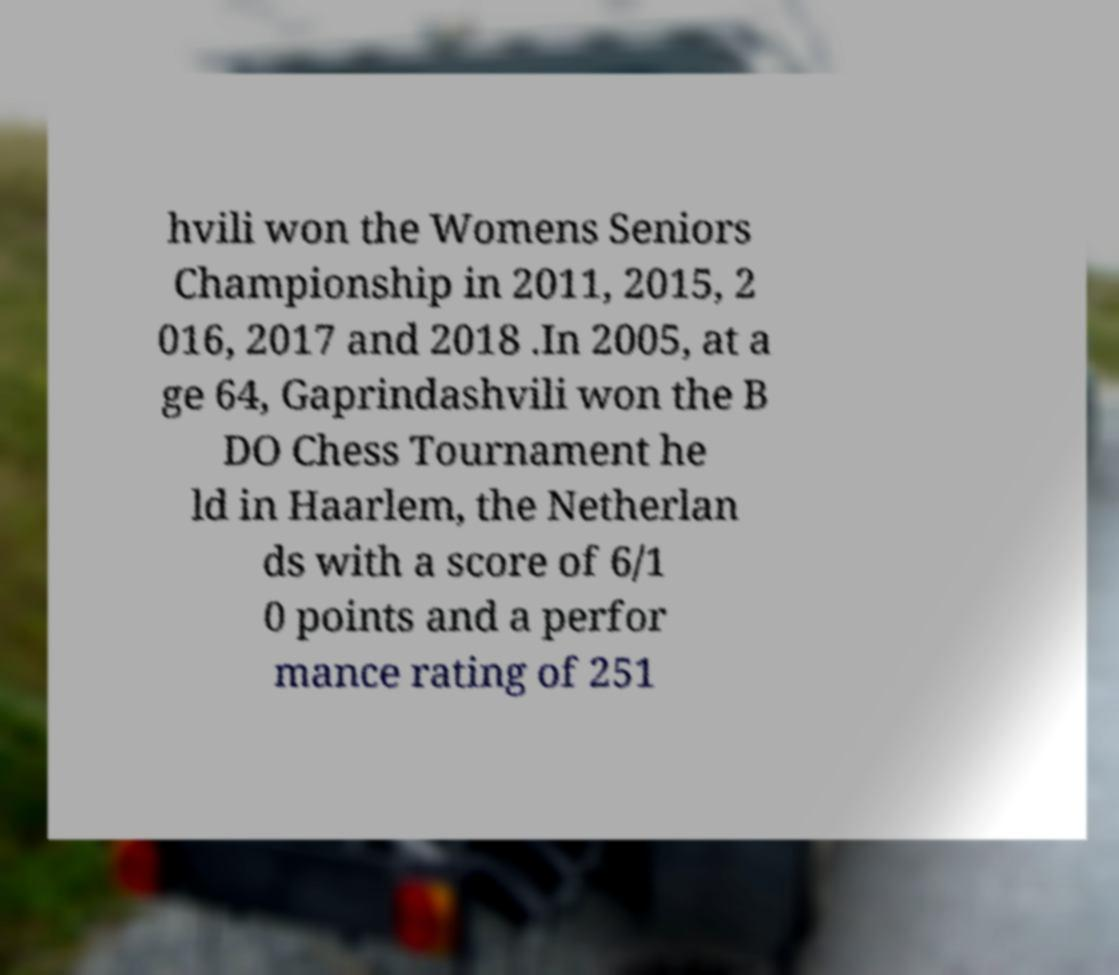For documentation purposes, I need the text within this image transcribed. Could you provide that? hvili won the Womens Seniors Championship in 2011, 2015, 2 016, 2017 and 2018 .In 2005, at a ge 64, Gaprindashvili won the B DO Chess Tournament he ld in Haarlem, the Netherlan ds with a score of 6/1 0 points and a perfor mance rating of 251 